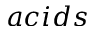Convert formula to latex. <formula><loc_0><loc_0><loc_500><loc_500>a c i d s</formula> 